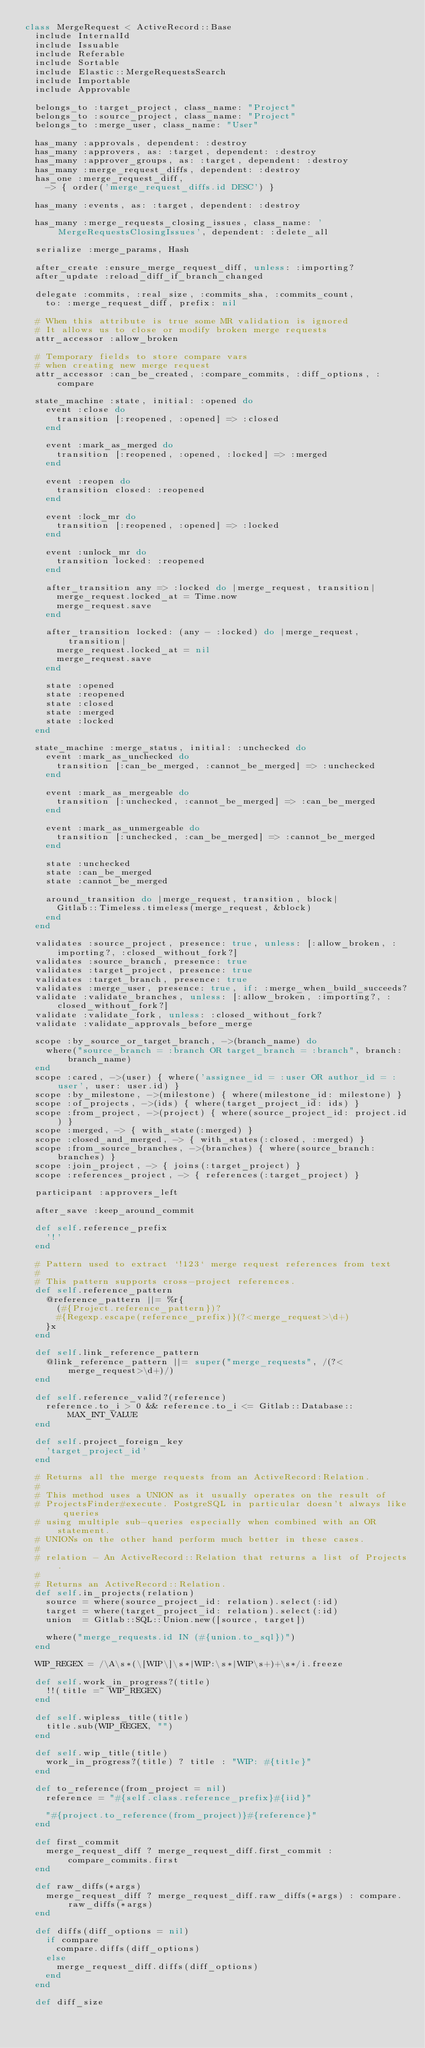<code> <loc_0><loc_0><loc_500><loc_500><_Ruby_>class MergeRequest < ActiveRecord::Base
  include InternalId
  include Issuable
  include Referable
  include Sortable
  include Elastic::MergeRequestsSearch
  include Importable
  include Approvable

  belongs_to :target_project, class_name: "Project"
  belongs_to :source_project, class_name: "Project"
  belongs_to :merge_user, class_name: "User"

  has_many :approvals, dependent: :destroy
  has_many :approvers, as: :target, dependent: :destroy
  has_many :approver_groups, as: :target, dependent: :destroy
  has_many :merge_request_diffs, dependent: :destroy
  has_one :merge_request_diff,
    -> { order('merge_request_diffs.id DESC') }

  has_many :events, as: :target, dependent: :destroy

  has_many :merge_requests_closing_issues, class_name: 'MergeRequestsClosingIssues', dependent: :delete_all

  serialize :merge_params, Hash

  after_create :ensure_merge_request_diff, unless: :importing?
  after_update :reload_diff_if_branch_changed

  delegate :commits, :real_size, :commits_sha, :commits_count,
    to: :merge_request_diff, prefix: nil

  # When this attribute is true some MR validation is ignored
  # It allows us to close or modify broken merge requests
  attr_accessor :allow_broken

  # Temporary fields to store compare vars
  # when creating new merge request
  attr_accessor :can_be_created, :compare_commits, :diff_options, :compare

  state_machine :state, initial: :opened do
    event :close do
      transition [:reopened, :opened] => :closed
    end

    event :mark_as_merged do
      transition [:reopened, :opened, :locked] => :merged
    end

    event :reopen do
      transition closed: :reopened
    end

    event :lock_mr do
      transition [:reopened, :opened] => :locked
    end

    event :unlock_mr do
      transition locked: :reopened
    end

    after_transition any => :locked do |merge_request, transition|
      merge_request.locked_at = Time.now
      merge_request.save
    end

    after_transition locked: (any - :locked) do |merge_request, transition|
      merge_request.locked_at = nil
      merge_request.save
    end

    state :opened
    state :reopened
    state :closed
    state :merged
    state :locked
  end

  state_machine :merge_status, initial: :unchecked do
    event :mark_as_unchecked do
      transition [:can_be_merged, :cannot_be_merged] => :unchecked
    end

    event :mark_as_mergeable do
      transition [:unchecked, :cannot_be_merged] => :can_be_merged
    end

    event :mark_as_unmergeable do
      transition [:unchecked, :can_be_merged] => :cannot_be_merged
    end

    state :unchecked
    state :can_be_merged
    state :cannot_be_merged

    around_transition do |merge_request, transition, block|
      Gitlab::Timeless.timeless(merge_request, &block)
    end
  end

  validates :source_project, presence: true, unless: [:allow_broken, :importing?, :closed_without_fork?]
  validates :source_branch, presence: true
  validates :target_project, presence: true
  validates :target_branch, presence: true
  validates :merge_user, presence: true, if: :merge_when_build_succeeds?
  validate :validate_branches, unless: [:allow_broken, :importing?, :closed_without_fork?]
  validate :validate_fork, unless: :closed_without_fork?
  validate :validate_approvals_before_merge

  scope :by_source_or_target_branch, ->(branch_name) do
    where("source_branch = :branch OR target_branch = :branch", branch: branch_name)
  end
  scope :cared, ->(user) { where('assignee_id = :user OR author_id = :user', user: user.id) }
  scope :by_milestone, ->(milestone) { where(milestone_id: milestone) }
  scope :of_projects, ->(ids) { where(target_project_id: ids) }
  scope :from_project, ->(project) { where(source_project_id: project.id) }
  scope :merged, -> { with_state(:merged) }
  scope :closed_and_merged, -> { with_states(:closed, :merged) }
  scope :from_source_branches, ->(branches) { where(source_branch: branches) }
  scope :join_project, -> { joins(:target_project) }
  scope :references_project, -> { references(:target_project) }

  participant :approvers_left

  after_save :keep_around_commit

  def self.reference_prefix
    '!'
  end

  # Pattern used to extract `!123` merge request references from text
  #
  # This pattern supports cross-project references.
  def self.reference_pattern
    @reference_pattern ||= %r{
      (#{Project.reference_pattern})?
      #{Regexp.escape(reference_prefix)}(?<merge_request>\d+)
    }x
  end

  def self.link_reference_pattern
    @link_reference_pattern ||= super("merge_requests", /(?<merge_request>\d+)/)
  end

  def self.reference_valid?(reference)
    reference.to_i > 0 && reference.to_i <= Gitlab::Database::MAX_INT_VALUE
  end

  def self.project_foreign_key
    'target_project_id'
  end

  # Returns all the merge requests from an ActiveRecord:Relation.
  #
  # This method uses a UNION as it usually operates on the result of
  # ProjectsFinder#execute. PostgreSQL in particular doesn't always like queries
  # using multiple sub-queries especially when combined with an OR statement.
  # UNIONs on the other hand perform much better in these cases.
  #
  # relation - An ActiveRecord::Relation that returns a list of Projects.
  #
  # Returns an ActiveRecord::Relation.
  def self.in_projects(relation)
    source = where(source_project_id: relation).select(:id)
    target = where(target_project_id: relation).select(:id)
    union  = Gitlab::SQL::Union.new([source, target])

    where("merge_requests.id IN (#{union.to_sql})")
  end

  WIP_REGEX = /\A\s*(\[WIP\]\s*|WIP:\s*|WIP\s+)+\s*/i.freeze

  def self.work_in_progress?(title)
    !!(title =~ WIP_REGEX)
  end

  def self.wipless_title(title)
    title.sub(WIP_REGEX, "")
  end

  def self.wip_title(title)
    work_in_progress?(title) ? title : "WIP: #{title}"
  end

  def to_reference(from_project = nil)
    reference = "#{self.class.reference_prefix}#{iid}"

    "#{project.to_reference(from_project)}#{reference}"
  end

  def first_commit
    merge_request_diff ? merge_request_diff.first_commit : compare_commits.first
  end

  def raw_diffs(*args)
    merge_request_diff ? merge_request_diff.raw_diffs(*args) : compare.raw_diffs(*args)
  end

  def diffs(diff_options = nil)
    if compare
      compare.diffs(diff_options)
    else
      merge_request_diff.diffs(diff_options)
    end
  end

  def diff_size</code> 